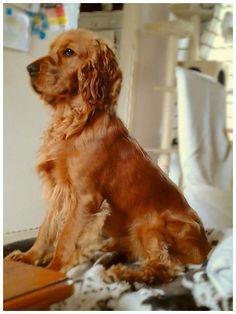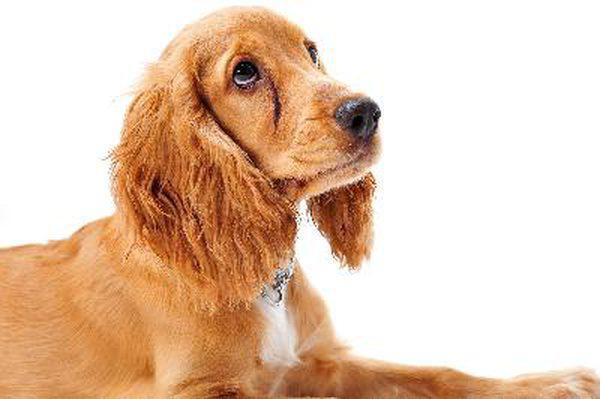The first image is the image on the left, the second image is the image on the right. Assess this claim about the two images: "a dog is in front of furniture on a wood floor". Correct or not? Answer yes or no. No. The first image is the image on the left, the second image is the image on the right. Analyze the images presented: Is the assertion "One dog is laying on a tile floor." valid? Answer yes or no. No. 